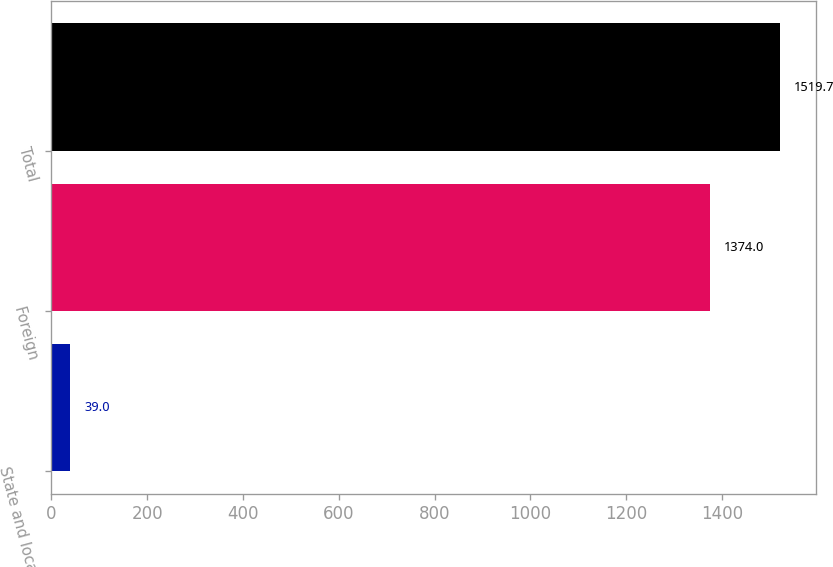Convert chart. <chart><loc_0><loc_0><loc_500><loc_500><bar_chart><fcel>State and local<fcel>Foreign<fcel>Total<nl><fcel>39<fcel>1374<fcel>1519.7<nl></chart> 